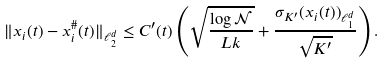<formula> <loc_0><loc_0><loc_500><loc_500>\| x _ { i } ( t ) - x _ { i } ^ { \# } ( t ) \| _ { \ell _ { 2 } ^ { d } } \leq C ^ { \prime } ( t ) \left ( \sqrt { \frac { \log { \mathcal { N } } } { L k } } + \frac { \sigma _ { K ^ { \prime } } ( x _ { i } ( t ) ) _ { \ell _ { 1 } ^ { d } } } { \sqrt { K ^ { \prime } } } \right ) .</formula> 